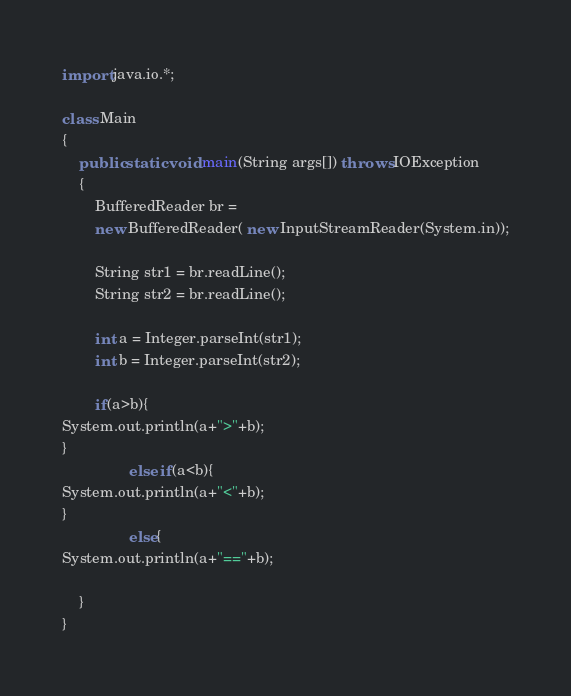<code> <loc_0><loc_0><loc_500><loc_500><_Java_>import java.io.*;

class Main
{
	public static void main(String args[]) throws IOException
	{
		BufferedReader br =
		new BufferedReader( new InputStreamReader(System.in));

		String str1 = br.readLine();
		String str2 = br.readLine();
		
		int a = Integer.parseInt(str1);
		int b = Integer.parseInt(str2);

		if(a>b){
System.out.println(a+">"+b);
}
                else if(a<b){
System.out.println(a+"<"+b);
}
                else{
System.out.println(a+"=="+b);

	}
}</code> 